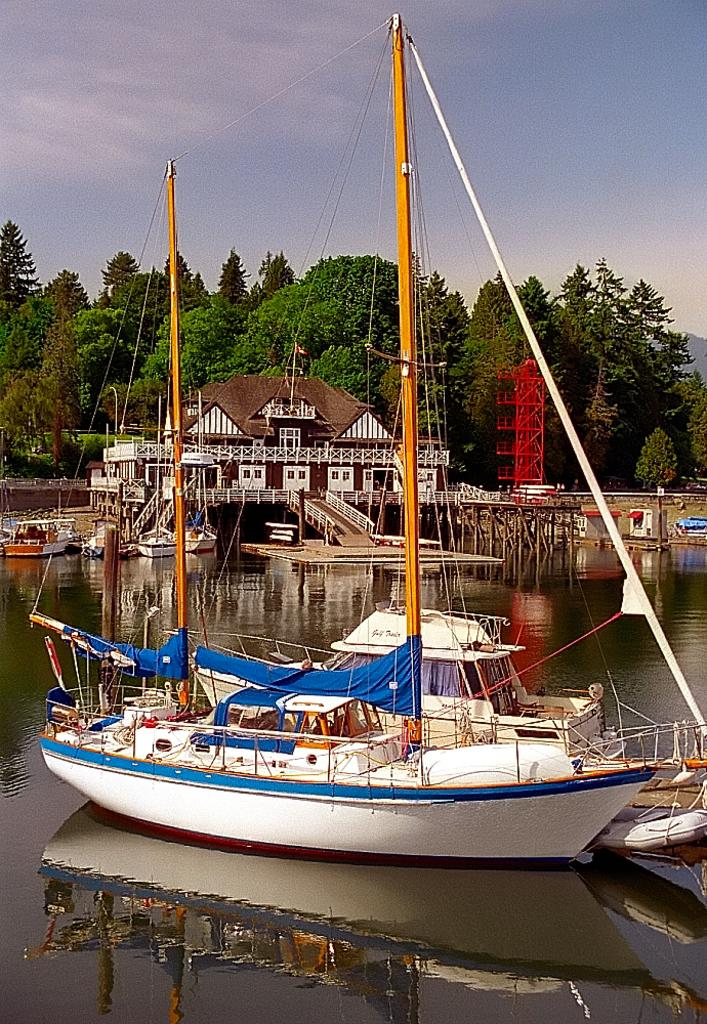What type of vehicles are in the water in the image? There are boats in the water in the image. What can be seen in the background of the image? There is a building, trees, and the sky visible in the background of the image. Where is the goat sitting on the cushion in the image? There is no goat or cushion present in the image. 